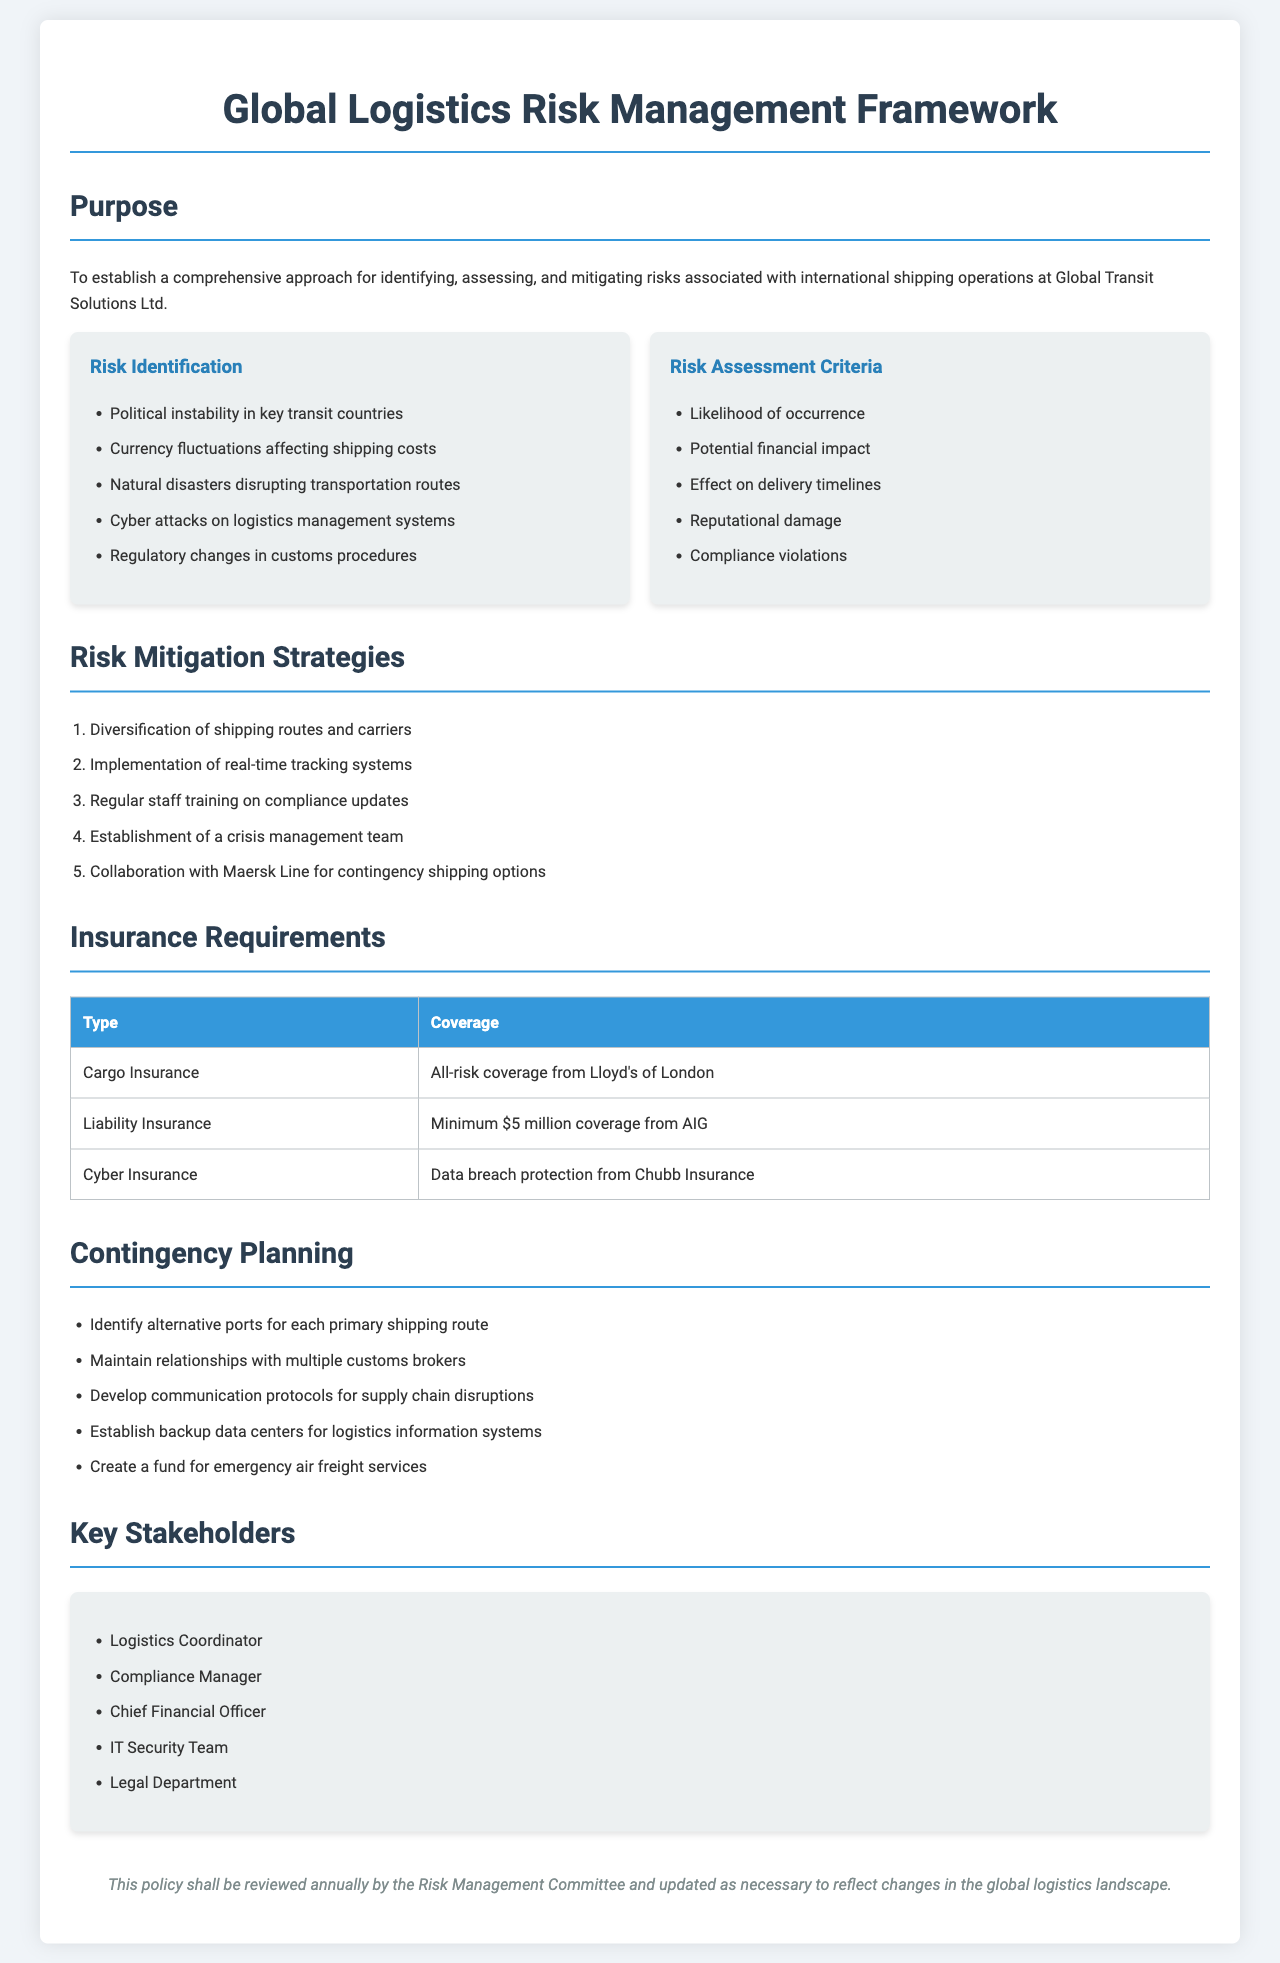What is the purpose of the document? The document aims to establish a comprehensive approach for identifying, assessing, and mitigating risks associated with international shipping operations at Global Transit Solutions Ltd.
Answer: To establish a comprehensive approach for identifying, assessing, and mitigating risks associated with international shipping operations at Global Transit Solutions Ltd What type of insurance provides all-risk coverage? The document specifies that Cargo Insurance provides all-risk coverage from Lloyd's of London.
Answer: Cargo Insurance What is the minimum coverage amount for Liability Insurance? The document states that Liability Insurance has a minimum coverage of $5 million from AIG.
Answer: $5 million How many key stakeholders are listed in the document? The document presents five key stakeholders involved in the risk management framework.
Answer: 5 What risk is associated with cyber attacks? The document identifies cyber attacks on logistics management systems as a risk.
Answer: Cyber attacks on logistics management systems Which company is mentioned for contingency shipping options? The document references collaboration with Maersk Line for contingency shipping options.
Answer: Maersk Line What is one strategy for risk mitigation? The document includes diversification of shipping routes and carriers as a risk mitigation strategy.
Answer: Diversification of shipping routes and carriers What should be maintained with multiple customs brokers? The document advises to maintain relationships with multiple customs brokers for effective contingency planning.
Answer: Relationships Who will review the policy annually? The document indicates that the Risk Management Committee will review the policy annually.
Answer: Risk Management Committee 